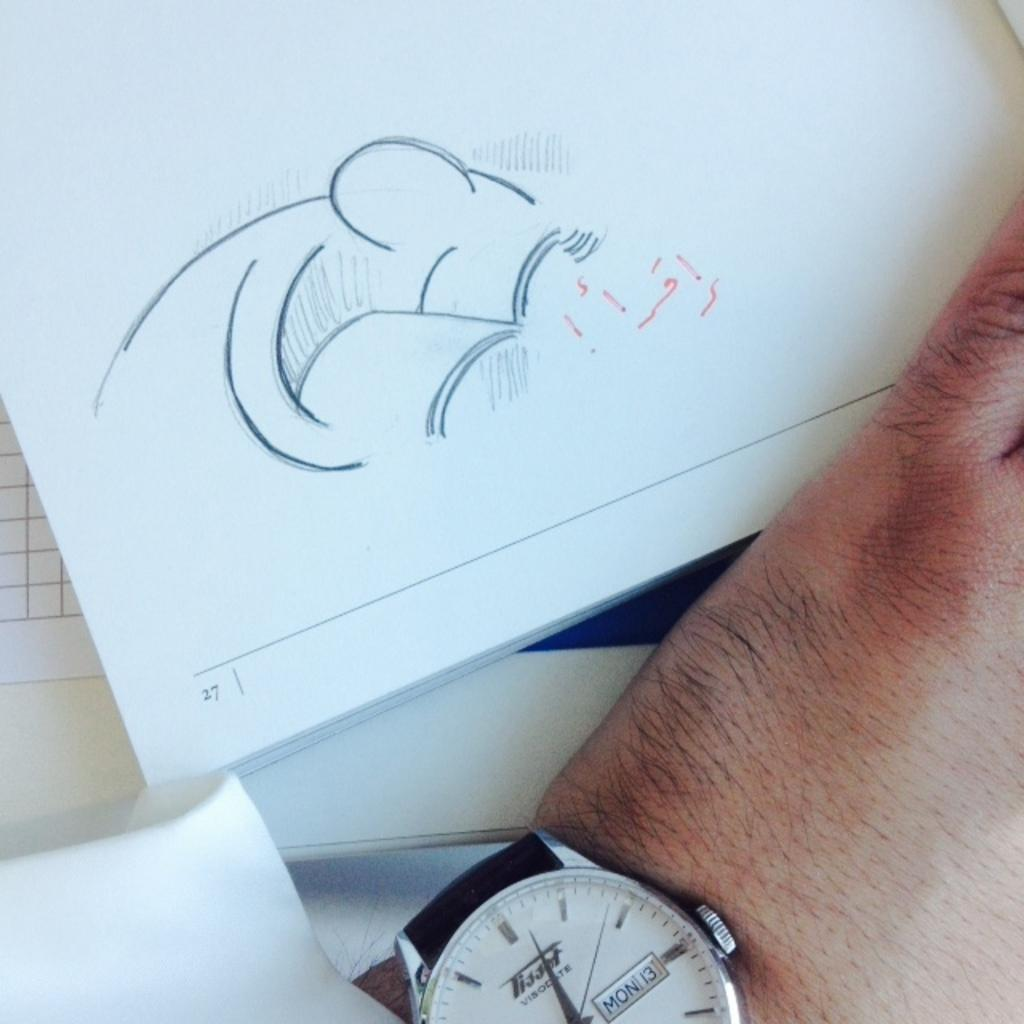<image>
Share a concise interpretation of the image provided. A book is open to page number 27. 